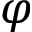Convert formula to latex. <formula><loc_0><loc_0><loc_500><loc_500>\varphi</formula> 